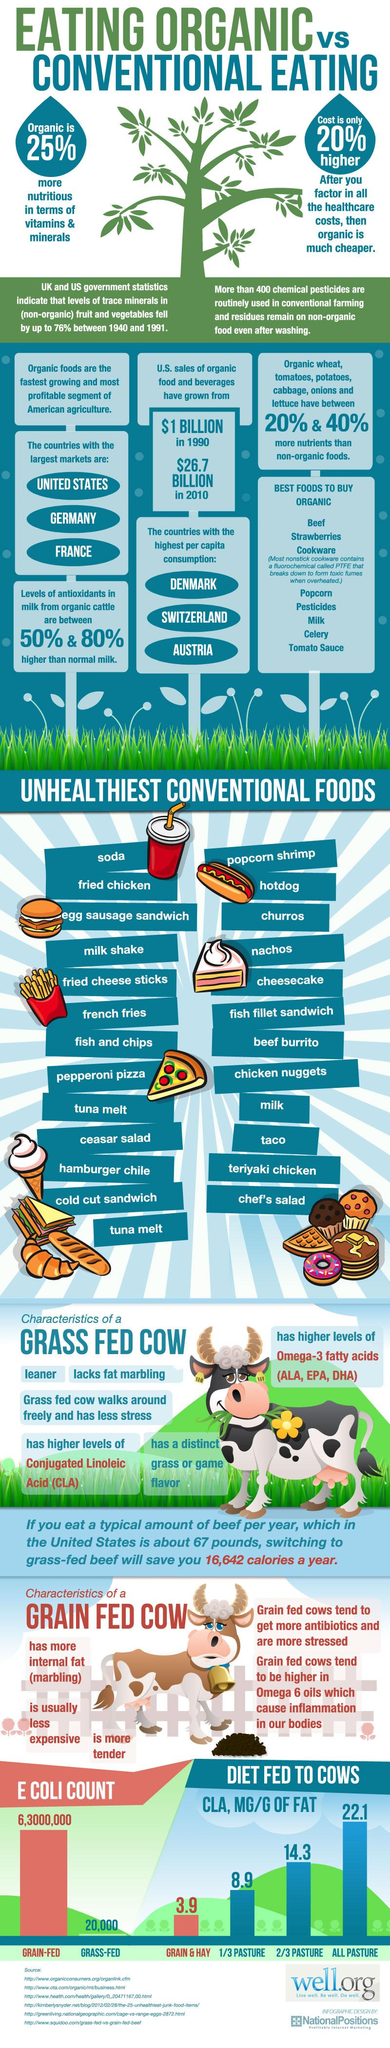Outline some significant characteristics in this image. Six consumable food items are listed in the best organic food. The difference in the concentration of conjugated linoleic acid (CLA) between grass-fed cows and grain-fed cows is 18.2%. Among the non-consumable items listed under the category of best foods to buy are cookware and pesticides. The difference in E. coli count between grain-fed and grass-fed cows is significant, with grass-fed cows having a count of 62,980,000 compared to grain-fed cows which have a count of 62,980,000. According to data from 1990 to 2010, the sales of organic food and beverages have shown a significant growth of $25.7 million. 